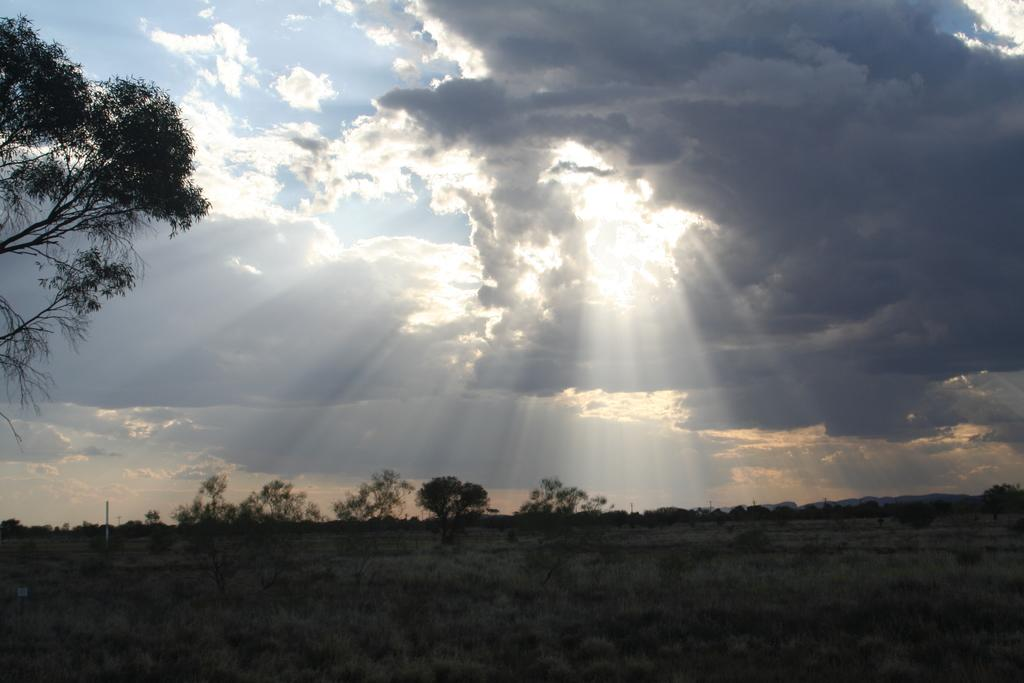What is the main subject of the image? The image depicts the ground. What type of vegetation can be seen in the image? There are trees in the image. What object is present in the image besides the trees and ground? There is a pole in the image. What can be seen in the background of the image? The sky is visible in the background of the image. How many tomatoes are hanging from the pole in the image? There are no tomatoes present in the image; it only features trees, a pole, and the ground. What caused the trees to grow in the image? The image does not provide information about the cause of the trees' growth; it only shows their presence. 